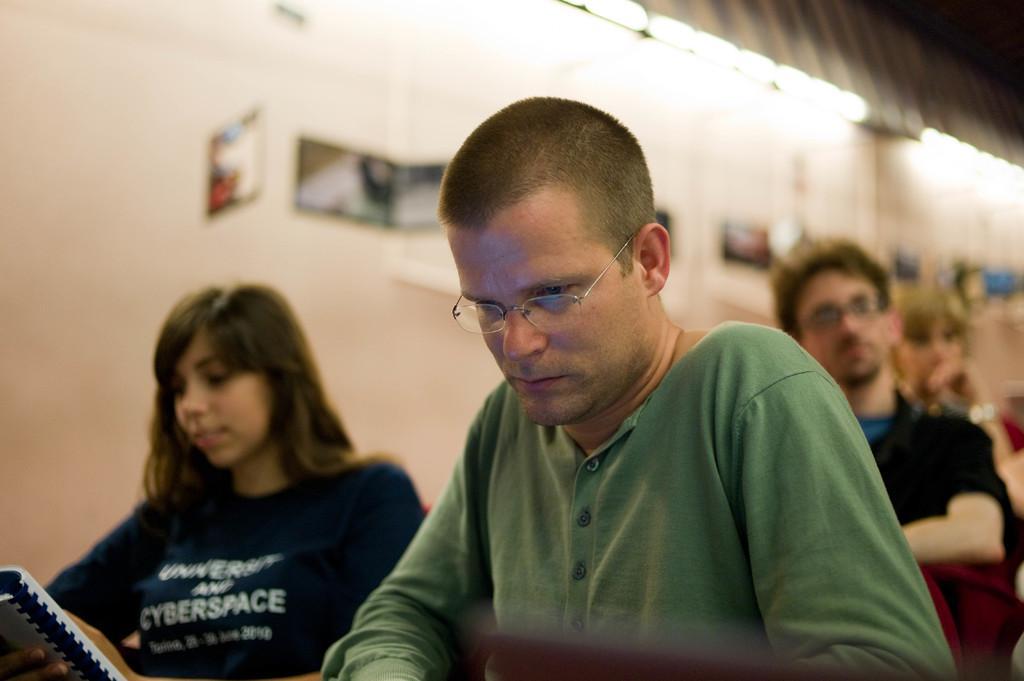Could you give a brief overview of what you see in this image? In this image I can see three people. In front the person is wearing green color shirt and woman is holding book. Back I can see building which is in white color. 